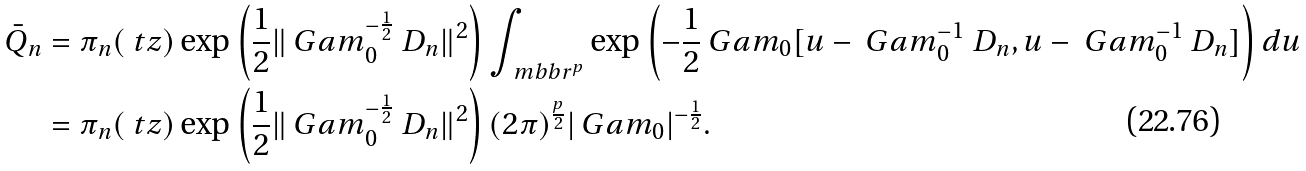Convert formula to latex. <formula><loc_0><loc_0><loc_500><loc_500>\bar { Q } _ { n } & = \pi _ { n } ( \ t z ) \exp \left ( \frac { 1 } { 2 } \| \ G a m _ { 0 } ^ { - \frac { 1 } { 2 } } \ D _ { n } \| ^ { 2 } \right ) \int _ { \ m b b r ^ { p } } \exp \left ( - \frac { 1 } { 2 } \ G a m _ { 0 } [ u - \ G a m _ { 0 } ^ { - 1 } \ D _ { n } , u - \ G a m _ { 0 } ^ { - 1 } \ D _ { n } ] \right ) d u \\ & = \pi _ { n } ( \ t z ) \exp \left ( \frac { 1 } { 2 } \| \ G a m _ { 0 } ^ { - \frac { 1 } { 2 } } \ D _ { n } \| ^ { 2 } \right ) ( 2 \pi ) ^ { \frac { p } { 2 } } | \ G a m _ { 0 } | ^ { - \frac { 1 } { 2 } } .</formula> 